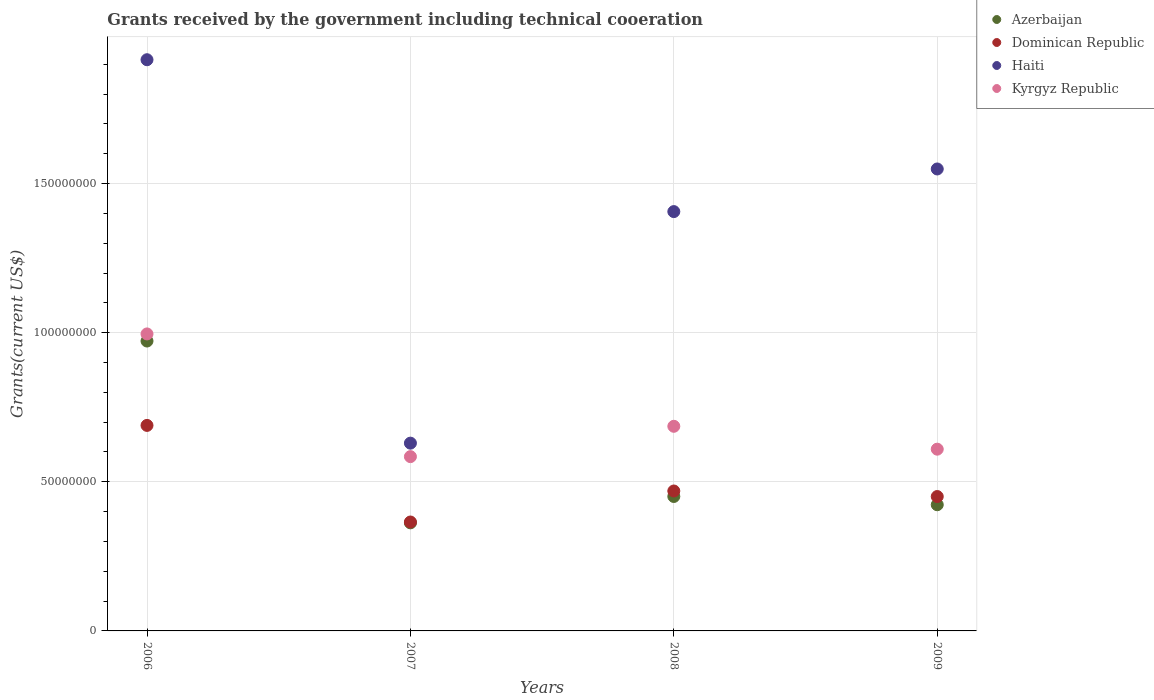How many different coloured dotlines are there?
Provide a short and direct response. 4. What is the total grants received by the government in Azerbaijan in 2008?
Your answer should be compact. 4.51e+07. Across all years, what is the maximum total grants received by the government in Haiti?
Offer a very short reply. 1.92e+08. Across all years, what is the minimum total grants received by the government in Dominican Republic?
Your response must be concise. 3.65e+07. In which year was the total grants received by the government in Haiti minimum?
Offer a very short reply. 2007. What is the total total grants received by the government in Dominican Republic in the graph?
Your answer should be compact. 1.97e+08. What is the difference between the total grants received by the government in Azerbaijan in 2006 and that in 2009?
Your answer should be compact. 5.49e+07. What is the difference between the total grants received by the government in Dominican Republic in 2007 and the total grants received by the government in Haiti in 2009?
Provide a short and direct response. -1.18e+08. What is the average total grants received by the government in Dominican Republic per year?
Your response must be concise. 4.94e+07. In the year 2008, what is the difference between the total grants received by the government in Kyrgyz Republic and total grants received by the government in Dominican Republic?
Keep it short and to the point. 2.17e+07. What is the ratio of the total grants received by the government in Dominican Republic in 2006 to that in 2008?
Offer a terse response. 1.47. Is the difference between the total grants received by the government in Kyrgyz Republic in 2007 and 2009 greater than the difference between the total grants received by the government in Dominican Republic in 2007 and 2009?
Ensure brevity in your answer.  Yes. What is the difference between the highest and the second highest total grants received by the government in Haiti?
Offer a terse response. 3.66e+07. What is the difference between the highest and the lowest total grants received by the government in Azerbaijan?
Your response must be concise. 6.10e+07. In how many years, is the total grants received by the government in Haiti greater than the average total grants received by the government in Haiti taken over all years?
Ensure brevity in your answer.  3. Is the sum of the total grants received by the government in Haiti in 2006 and 2009 greater than the maximum total grants received by the government in Azerbaijan across all years?
Your response must be concise. Yes. Is it the case that in every year, the sum of the total grants received by the government in Azerbaijan and total grants received by the government in Haiti  is greater than the sum of total grants received by the government in Dominican Republic and total grants received by the government in Kyrgyz Republic?
Offer a terse response. Yes. Is it the case that in every year, the sum of the total grants received by the government in Kyrgyz Republic and total grants received by the government in Haiti  is greater than the total grants received by the government in Dominican Republic?
Provide a succinct answer. Yes. Does the total grants received by the government in Haiti monotonically increase over the years?
Give a very brief answer. No. Is the total grants received by the government in Haiti strictly less than the total grants received by the government in Dominican Republic over the years?
Provide a succinct answer. No. How many dotlines are there?
Provide a short and direct response. 4. Does the graph contain any zero values?
Ensure brevity in your answer.  No. How many legend labels are there?
Make the answer very short. 4. What is the title of the graph?
Keep it short and to the point. Grants received by the government including technical cooeration. What is the label or title of the Y-axis?
Your response must be concise. Grants(current US$). What is the Grants(current US$) in Azerbaijan in 2006?
Provide a short and direct response. 9.72e+07. What is the Grants(current US$) of Dominican Republic in 2006?
Provide a succinct answer. 6.89e+07. What is the Grants(current US$) of Haiti in 2006?
Keep it short and to the point. 1.92e+08. What is the Grants(current US$) in Kyrgyz Republic in 2006?
Make the answer very short. 9.96e+07. What is the Grants(current US$) in Azerbaijan in 2007?
Provide a succinct answer. 3.62e+07. What is the Grants(current US$) of Dominican Republic in 2007?
Your answer should be very brief. 3.65e+07. What is the Grants(current US$) in Haiti in 2007?
Make the answer very short. 6.30e+07. What is the Grants(current US$) in Kyrgyz Republic in 2007?
Ensure brevity in your answer.  5.84e+07. What is the Grants(current US$) of Azerbaijan in 2008?
Offer a terse response. 4.51e+07. What is the Grants(current US$) in Dominican Republic in 2008?
Ensure brevity in your answer.  4.69e+07. What is the Grants(current US$) in Haiti in 2008?
Keep it short and to the point. 1.41e+08. What is the Grants(current US$) of Kyrgyz Republic in 2008?
Offer a very short reply. 6.86e+07. What is the Grants(current US$) of Azerbaijan in 2009?
Offer a very short reply. 4.23e+07. What is the Grants(current US$) in Dominican Republic in 2009?
Ensure brevity in your answer.  4.51e+07. What is the Grants(current US$) of Haiti in 2009?
Make the answer very short. 1.55e+08. What is the Grants(current US$) in Kyrgyz Republic in 2009?
Offer a terse response. 6.09e+07. Across all years, what is the maximum Grants(current US$) in Azerbaijan?
Give a very brief answer. 9.72e+07. Across all years, what is the maximum Grants(current US$) in Dominican Republic?
Your response must be concise. 6.89e+07. Across all years, what is the maximum Grants(current US$) of Haiti?
Offer a very short reply. 1.92e+08. Across all years, what is the maximum Grants(current US$) of Kyrgyz Republic?
Provide a short and direct response. 9.96e+07. Across all years, what is the minimum Grants(current US$) in Azerbaijan?
Offer a very short reply. 3.62e+07. Across all years, what is the minimum Grants(current US$) of Dominican Republic?
Your answer should be very brief. 3.65e+07. Across all years, what is the minimum Grants(current US$) in Haiti?
Keep it short and to the point. 6.30e+07. Across all years, what is the minimum Grants(current US$) in Kyrgyz Republic?
Your answer should be compact. 5.84e+07. What is the total Grants(current US$) of Azerbaijan in the graph?
Make the answer very short. 2.21e+08. What is the total Grants(current US$) in Dominican Republic in the graph?
Keep it short and to the point. 1.97e+08. What is the total Grants(current US$) of Haiti in the graph?
Offer a terse response. 5.50e+08. What is the total Grants(current US$) in Kyrgyz Republic in the graph?
Ensure brevity in your answer.  2.88e+08. What is the difference between the Grants(current US$) of Azerbaijan in 2006 and that in 2007?
Make the answer very short. 6.10e+07. What is the difference between the Grants(current US$) in Dominican Republic in 2006 and that in 2007?
Give a very brief answer. 3.24e+07. What is the difference between the Grants(current US$) in Haiti in 2006 and that in 2007?
Your response must be concise. 1.29e+08. What is the difference between the Grants(current US$) of Kyrgyz Republic in 2006 and that in 2007?
Offer a very short reply. 4.11e+07. What is the difference between the Grants(current US$) in Azerbaijan in 2006 and that in 2008?
Offer a very short reply. 5.21e+07. What is the difference between the Grants(current US$) in Dominican Republic in 2006 and that in 2008?
Provide a short and direct response. 2.20e+07. What is the difference between the Grants(current US$) in Haiti in 2006 and that in 2008?
Your response must be concise. 5.09e+07. What is the difference between the Grants(current US$) in Kyrgyz Republic in 2006 and that in 2008?
Your answer should be compact. 3.10e+07. What is the difference between the Grants(current US$) in Azerbaijan in 2006 and that in 2009?
Give a very brief answer. 5.49e+07. What is the difference between the Grants(current US$) in Dominican Republic in 2006 and that in 2009?
Offer a very short reply. 2.38e+07. What is the difference between the Grants(current US$) in Haiti in 2006 and that in 2009?
Provide a succinct answer. 3.66e+07. What is the difference between the Grants(current US$) in Kyrgyz Republic in 2006 and that in 2009?
Your answer should be very brief. 3.86e+07. What is the difference between the Grants(current US$) in Azerbaijan in 2007 and that in 2008?
Ensure brevity in your answer.  -8.84e+06. What is the difference between the Grants(current US$) in Dominican Republic in 2007 and that in 2008?
Provide a short and direct response. -1.04e+07. What is the difference between the Grants(current US$) in Haiti in 2007 and that in 2008?
Ensure brevity in your answer.  -7.76e+07. What is the difference between the Grants(current US$) of Kyrgyz Republic in 2007 and that in 2008?
Ensure brevity in your answer.  -1.02e+07. What is the difference between the Grants(current US$) in Azerbaijan in 2007 and that in 2009?
Offer a very short reply. -6.07e+06. What is the difference between the Grants(current US$) of Dominican Republic in 2007 and that in 2009?
Keep it short and to the point. -8.54e+06. What is the difference between the Grants(current US$) in Haiti in 2007 and that in 2009?
Keep it short and to the point. -9.19e+07. What is the difference between the Grants(current US$) of Kyrgyz Republic in 2007 and that in 2009?
Your response must be concise. -2.50e+06. What is the difference between the Grants(current US$) in Azerbaijan in 2008 and that in 2009?
Provide a succinct answer. 2.77e+06. What is the difference between the Grants(current US$) in Dominican Republic in 2008 and that in 2009?
Offer a very short reply. 1.86e+06. What is the difference between the Grants(current US$) of Haiti in 2008 and that in 2009?
Make the answer very short. -1.43e+07. What is the difference between the Grants(current US$) in Kyrgyz Republic in 2008 and that in 2009?
Offer a terse response. 7.67e+06. What is the difference between the Grants(current US$) in Azerbaijan in 2006 and the Grants(current US$) in Dominican Republic in 2007?
Give a very brief answer. 6.07e+07. What is the difference between the Grants(current US$) in Azerbaijan in 2006 and the Grants(current US$) in Haiti in 2007?
Make the answer very short. 3.42e+07. What is the difference between the Grants(current US$) in Azerbaijan in 2006 and the Grants(current US$) in Kyrgyz Republic in 2007?
Provide a short and direct response. 3.88e+07. What is the difference between the Grants(current US$) in Dominican Republic in 2006 and the Grants(current US$) in Haiti in 2007?
Keep it short and to the point. 5.95e+06. What is the difference between the Grants(current US$) of Dominican Republic in 2006 and the Grants(current US$) of Kyrgyz Republic in 2007?
Your response must be concise. 1.05e+07. What is the difference between the Grants(current US$) of Haiti in 2006 and the Grants(current US$) of Kyrgyz Republic in 2007?
Your response must be concise. 1.33e+08. What is the difference between the Grants(current US$) in Azerbaijan in 2006 and the Grants(current US$) in Dominican Republic in 2008?
Provide a succinct answer. 5.03e+07. What is the difference between the Grants(current US$) of Azerbaijan in 2006 and the Grants(current US$) of Haiti in 2008?
Your answer should be very brief. -4.34e+07. What is the difference between the Grants(current US$) of Azerbaijan in 2006 and the Grants(current US$) of Kyrgyz Republic in 2008?
Give a very brief answer. 2.86e+07. What is the difference between the Grants(current US$) of Dominican Republic in 2006 and the Grants(current US$) of Haiti in 2008?
Provide a short and direct response. -7.17e+07. What is the difference between the Grants(current US$) in Haiti in 2006 and the Grants(current US$) in Kyrgyz Republic in 2008?
Provide a succinct answer. 1.23e+08. What is the difference between the Grants(current US$) of Azerbaijan in 2006 and the Grants(current US$) of Dominican Republic in 2009?
Your response must be concise. 5.21e+07. What is the difference between the Grants(current US$) in Azerbaijan in 2006 and the Grants(current US$) in Haiti in 2009?
Ensure brevity in your answer.  -5.77e+07. What is the difference between the Grants(current US$) of Azerbaijan in 2006 and the Grants(current US$) of Kyrgyz Republic in 2009?
Your answer should be very brief. 3.63e+07. What is the difference between the Grants(current US$) of Dominican Republic in 2006 and the Grants(current US$) of Haiti in 2009?
Offer a terse response. -8.60e+07. What is the difference between the Grants(current US$) of Dominican Republic in 2006 and the Grants(current US$) of Kyrgyz Republic in 2009?
Keep it short and to the point. 7.97e+06. What is the difference between the Grants(current US$) of Haiti in 2006 and the Grants(current US$) of Kyrgyz Republic in 2009?
Offer a terse response. 1.31e+08. What is the difference between the Grants(current US$) of Azerbaijan in 2007 and the Grants(current US$) of Dominican Republic in 2008?
Your answer should be very brief. -1.07e+07. What is the difference between the Grants(current US$) in Azerbaijan in 2007 and the Grants(current US$) in Haiti in 2008?
Your answer should be compact. -1.04e+08. What is the difference between the Grants(current US$) in Azerbaijan in 2007 and the Grants(current US$) in Kyrgyz Republic in 2008?
Give a very brief answer. -3.24e+07. What is the difference between the Grants(current US$) of Dominican Republic in 2007 and the Grants(current US$) of Haiti in 2008?
Your answer should be very brief. -1.04e+08. What is the difference between the Grants(current US$) of Dominican Republic in 2007 and the Grants(current US$) of Kyrgyz Republic in 2008?
Ensure brevity in your answer.  -3.21e+07. What is the difference between the Grants(current US$) of Haiti in 2007 and the Grants(current US$) of Kyrgyz Republic in 2008?
Your response must be concise. -5.65e+06. What is the difference between the Grants(current US$) in Azerbaijan in 2007 and the Grants(current US$) in Dominican Republic in 2009?
Your response must be concise. -8.82e+06. What is the difference between the Grants(current US$) of Azerbaijan in 2007 and the Grants(current US$) of Haiti in 2009?
Offer a terse response. -1.19e+08. What is the difference between the Grants(current US$) of Azerbaijan in 2007 and the Grants(current US$) of Kyrgyz Republic in 2009?
Give a very brief answer. -2.47e+07. What is the difference between the Grants(current US$) in Dominican Republic in 2007 and the Grants(current US$) in Haiti in 2009?
Your answer should be compact. -1.18e+08. What is the difference between the Grants(current US$) of Dominican Republic in 2007 and the Grants(current US$) of Kyrgyz Republic in 2009?
Your answer should be compact. -2.44e+07. What is the difference between the Grants(current US$) in Haiti in 2007 and the Grants(current US$) in Kyrgyz Republic in 2009?
Your answer should be compact. 2.02e+06. What is the difference between the Grants(current US$) of Azerbaijan in 2008 and the Grants(current US$) of Haiti in 2009?
Your answer should be compact. -1.10e+08. What is the difference between the Grants(current US$) of Azerbaijan in 2008 and the Grants(current US$) of Kyrgyz Republic in 2009?
Give a very brief answer. -1.59e+07. What is the difference between the Grants(current US$) of Dominican Republic in 2008 and the Grants(current US$) of Haiti in 2009?
Offer a very short reply. -1.08e+08. What is the difference between the Grants(current US$) in Dominican Republic in 2008 and the Grants(current US$) in Kyrgyz Republic in 2009?
Offer a terse response. -1.40e+07. What is the difference between the Grants(current US$) in Haiti in 2008 and the Grants(current US$) in Kyrgyz Republic in 2009?
Provide a succinct answer. 7.97e+07. What is the average Grants(current US$) of Azerbaijan per year?
Keep it short and to the point. 5.52e+07. What is the average Grants(current US$) in Dominican Republic per year?
Your answer should be compact. 4.94e+07. What is the average Grants(current US$) in Haiti per year?
Keep it short and to the point. 1.37e+08. What is the average Grants(current US$) in Kyrgyz Republic per year?
Ensure brevity in your answer.  7.19e+07. In the year 2006, what is the difference between the Grants(current US$) of Azerbaijan and Grants(current US$) of Dominican Republic?
Your answer should be very brief. 2.83e+07. In the year 2006, what is the difference between the Grants(current US$) in Azerbaijan and Grants(current US$) in Haiti?
Keep it short and to the point. -9.43e+07. In the year 2006, what is the difference between the Grants(current US$) in Azerbaijan and Grants(current US$) in Kyrgyz Republic?
Keep it short and to the point. -2.38e+06. In the year 2006, what is the difference between the Grants(current US$) in Dominican Republic and Grants(current US$) in Haiti?
Ensure brevity in your answer.  -1.23e+08. In the year 2006, what is the difference between the Grants(current US$) of Dominican Republic and Grants(current US$) of Kyrgyz Republic?
Your answer should be compact. -3.07e+07. In the year 2006, what is the difference between the Grants(current US$) of Haiti and Grants(current US$) of Kyrgyz Republic?
Make the answer very short. 9.19e+07. In the year 2007, what is the difference between the Grants(current US$) of Azerbaijan and Grants(current US$) of Dominican Republic?
Your response must be concise. -2.80e+05. In the year 2007, what is the difference between the Grants(current US$) of Azerbaijan and Grants(current US$) of Haiti?
Your response must be concise. -2.67e+07. In the year 2007, what is the difference between the Grants(current US$) in Azerbaijan and Grants(current US$) in Kyrgyz Republic?
Make the answer very short. -2.22e+07. In the year 2007, what is the difference between the Grants(current US$) in Dominican Republic and Grants(current US$) in Haiti?
Keep it short and to the point. -2.64e+07. In the year 2007, what is the difference between the Grants(current US$) of Dominican Republic and Grants(current US$) of Kyrgyz Republic?
Offer a terse response. -2.19e+07. In the year 2007, what is the difference between the Grants(current US$) of Haiti and Grants(current US$) of Kyrgyz Republic?
Provide a short and direct response. 4.52e+06. In the year 2008, what is the difference between the Grants(current US$) in Azerbaijan and Grants(current US$) in Dominican Republic?
Offer a very short reply. -1.84e+06. In the year 2008, what is the difference between the Grants(current US$) of Azerbaijan and Grants(current US$) of Haiti?
Your response must be concise. -9.55e+07. In the year 2008, what is the difference between the Grants(current US$) in Azerbaijan and Grants(current US$) in Kyrgyz Republic?
Your answer should be very brief. -2.35e+07. In the year 2008, what is the difference between the Grants(current US$) in Dominican Republic and Grants(current US$) in Haiti?
Ensure brevity in your answer.  -9.37e+07. In the year 2008, what is the difference between the Grants(current US$) in Dominican Republic and Grants(current US$) in Kyrgyz Republic?
Give a very brief answer. -2.17e+07. In the year 2008, what is the difference between the Grants(current US$) in Haiti and Grants(current US$) in Kyrgyz Republic?
Provide a short and direct response. 7.20e+07. In the year 2009, what is the difference between the Grants(current US$) in Azerbaijan and Grants(current US$) in Dominican Republic?
Your answer should be compact. -2.75e+06. In the year 2009, what is the difference between the Grants(current US$) of Azerbaijan and Grants(current US$) of Haiti?
Your response must be concise. -1.13e+08. In the year 2009, what is the difference between the Grants(current US$) in Azerbaijan and Grants(current US$) in Kyrgyz Republic?
Make the answer very short. -1.86e+07. In the year 2009, what is the difference between the Grants(current US$) in Dominican Republic and Grants(current US$) in Haiti?
Your answer should be very brief. -1.10e+08. In the year 2009, what is the difference between the Grants(current US$) in Dominican Republic and Grants(current US$) in Kyrgyz Republic?
Offer a terse response. -1.59e+07. In the year 2009, what is the difference between the Grants(current US$) of Haiti and Grants(current US$) of Kyrgyz Republic?
Provide a succinct answer. 9.40e+07. What is the ratio of the Grants(current US$) of Azerbaijan in 2006 to that in 2007?
Offer a very short reply. 2.68. What is the ratio of the Grants(current US$) of Dominican Republic in 2006 to that in 2007?
Your response must be concise. 1.89. What is the ratio of the Grants(current US$) in Haiti in 2006 to that in 2007?
Keep it short and to the point. 3.04. What is the ratio of the Grants(current US$) of Kyrgyz Republic in 2006 to that in 2007?
Provide a succinct answer. 1.7. What is the ratio of the Grants(current US$) of Azerbaijan in 2006 to that in 2008?
Make the answer very short. 2.16. What is the ratio of the Grants(current US$) in Dominican Republic in 2006 to that in 2008?
Give a very brief answer. 1.47. What is the ratio of the Grants(current US$) in Haiti in 2006 to that in 2008?
Provide a short and direct response. 1.36. What is the ratio of the Grants(current US$) of Kyrgyz Republic in 2006 to that in 2008?
Your answer should be compact. 1.45. What is the ratio of the Grants(current US$) of Azerbaijan in 2006 to that in 2009?
Provide a succinct answer. 2.3. What is the ratio of the Grants(current US$) in Dominican Republic in 2006 to that in 2009?
Keep it short and to the point. 1.53. What is the ratio of the Grants(current US$) in Haiti in 2006 to that in 2009?
Offer a very short reply. 1.24. What is the ratio of the Grants(current US$) in Kyrgyz Republic in 2006 to that in 2009?
Offer a very short reply. 1.63. What is the ratio of the Grants(current US$) of Azerbaijan in 2007 to that in 2008?
Make the answer very short. 0.8. What is the ratio of the Grants(current US$) in Dominican Republic in 2007 to that in 2008?
Provide a short and direct response. 0.78. What is the ratio of the Grants(current US$) of Haiti in 2007 to that in 2008?
Keep it short and to the point. 0.45. What is the ratio of the Grants(current US$) in Kyrgyz Republic in 2007 to that in 2008?
Your answer should be compact. 0.85. What is the ratio of the Grants(current US$) of Azerbaijan in 2007 to that in 2009?
Your answer should be compact. 0.86. What is the ratio of the Grants(current US$) in Dominican Republic in 2007 to that in 2009?
Offer a terse response. 0.81. What is the ratio of the Grants(current US$) of Haiti in 2007 to that in 2009?
Make the answer very short. 0.41. What is the ratio of the Grants(current US$) in Azerbaijan in 2008 to that in 2009?
Keep it short and to the point. 1.07. What is the ratio of the Grants(current US$) of Dominican Republic in 2008 to that in 2009?
Offer a very short reply. 1.04. What is the ratio of the Grants(current US$) in Haiti in 2008 to that in 2009?
Make the answer very short. 0.91. What is the ratio of the Grants(current US$) of Kyrgyz Republic in 2008 to that in 2009?
Ensure brevity in your answer.  1.13. What is the difference between the highest and the second highest Grants(current US$) in Azerbaijan?
Keep it short and to the point. 5.21e+07. What is the difference between the highest and the second highest Grants(current US$) of Dominican Republic?
Give a very brief answer. 2.20e+07. What is the difference between the highest and the second highest Grants(current US$) of Haiti?
Provide a short and direct response. 3.66e+07. What is the difference between the highest and the second highest Grants(current US$) of Kyrgyz Republic?
Offer a very short reply. 3.10e+07. What is the difference between the highest and the lowest Grants(current US$) of Azerbaijan?
Give a very brief answer. 6.10e+07. What is the difference between the highest and the lowest Grants(current US$) in Dominican Republic?
Give a very brief answer. 3.24e+07. What is the difference between the highest and the lowest Grants(current US$) of Haiti?
Your answer should be compact. 1.29e+08. What is the difference between the highest and the lowest Grants(current US$) in Kyrgyz Republic?
Your answer should be compact. 4.11e+07. 